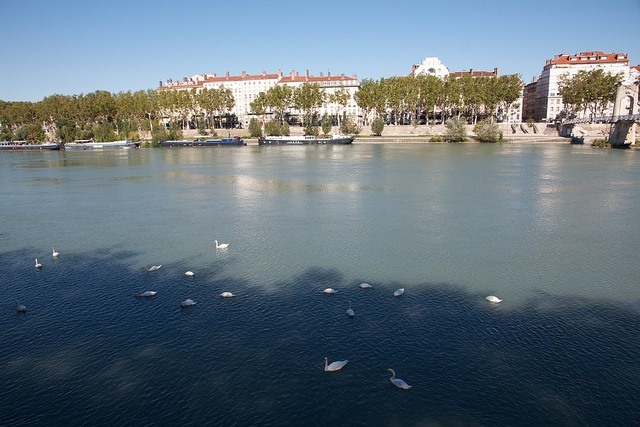Describe the objects in this image and their specific colors. I can see bird in gray, navy, blue, and black tones, boat in gray, white, darkgray, and tan tones, boat in gray, white, darkgray, and lightblue tones, boat in gray, black, and darkgray tones, and boat in gray, lightgray, olive, and black tones in this image. 